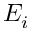Convert formula to latex. <formula><loc_0><loc_0><loc_500><loc_500>E _ { i }</formula> 